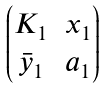Convert formula to latex. <formula><loc_0><loc_0><loc_500><loc_500>\begin{pmatrix} K _ { 1 } & x _ { 1 } \\ \bar { y } _ { 1 } & a _ { 1 } \end{pmatrix}</formula> 